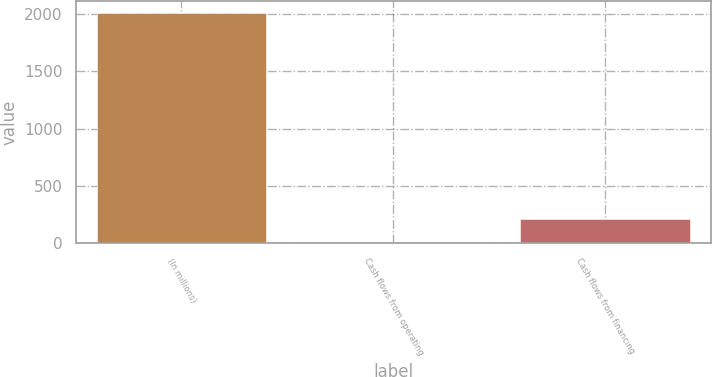<chart> <loc_0><loc_0><loc_500><loc_500><bar_chart><fcel>(In millions)<fcel>Cash flows from operating<fcel>Cash flows from financing<nl><fcel>2006<fcel>11<fcel>210.5<nl></chart> 